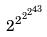<formula> <loc_0><loc_0><loc_500><loc_500>2 ^ { 2 ^ { 2 ^ { 2 ^ { 4 3 } } } }</formula> 